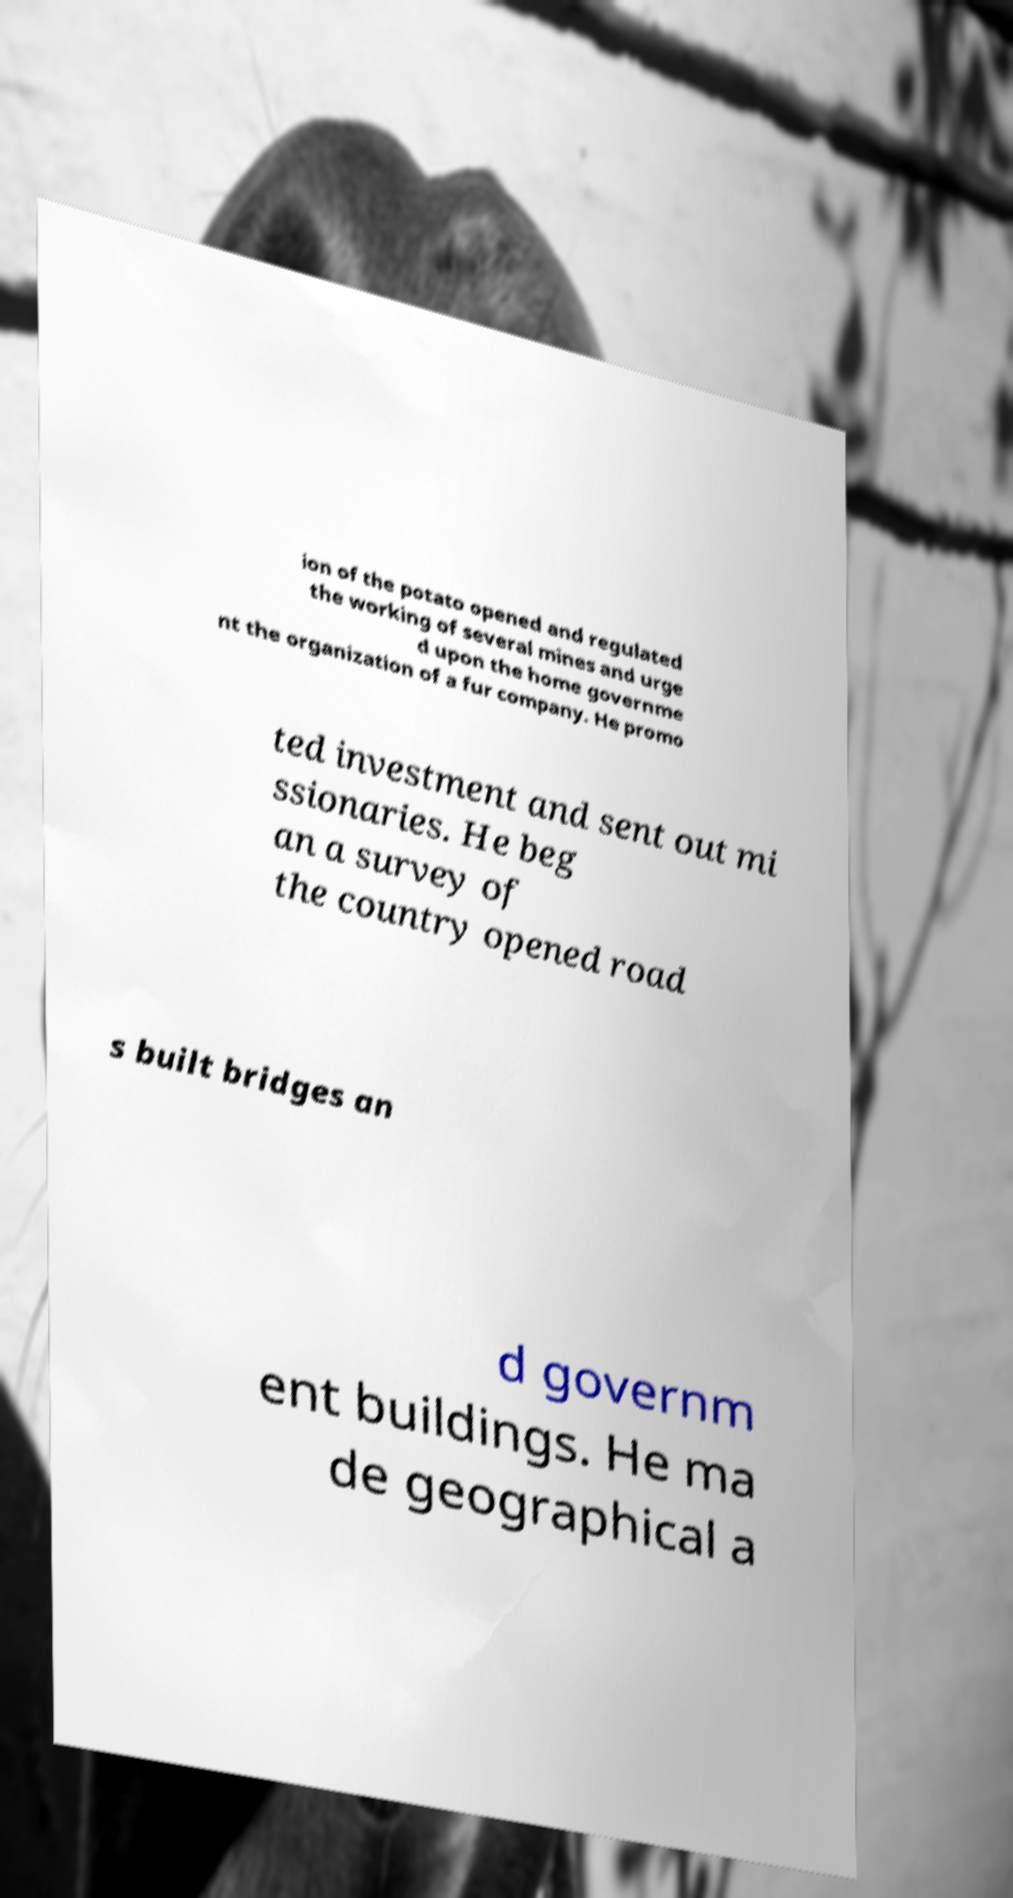There's text embedded in this image that I need extracted. Can you transcribe it verbatim? ion of the potato opened and regulated the working of several mines and urge d upon the home governme nt the organization of a fur company. He promo ted investment and sent out mi ssionaries. He beg an a survey of the country opened road s built bridges an d governm ent buildings. He ma de geographical a 